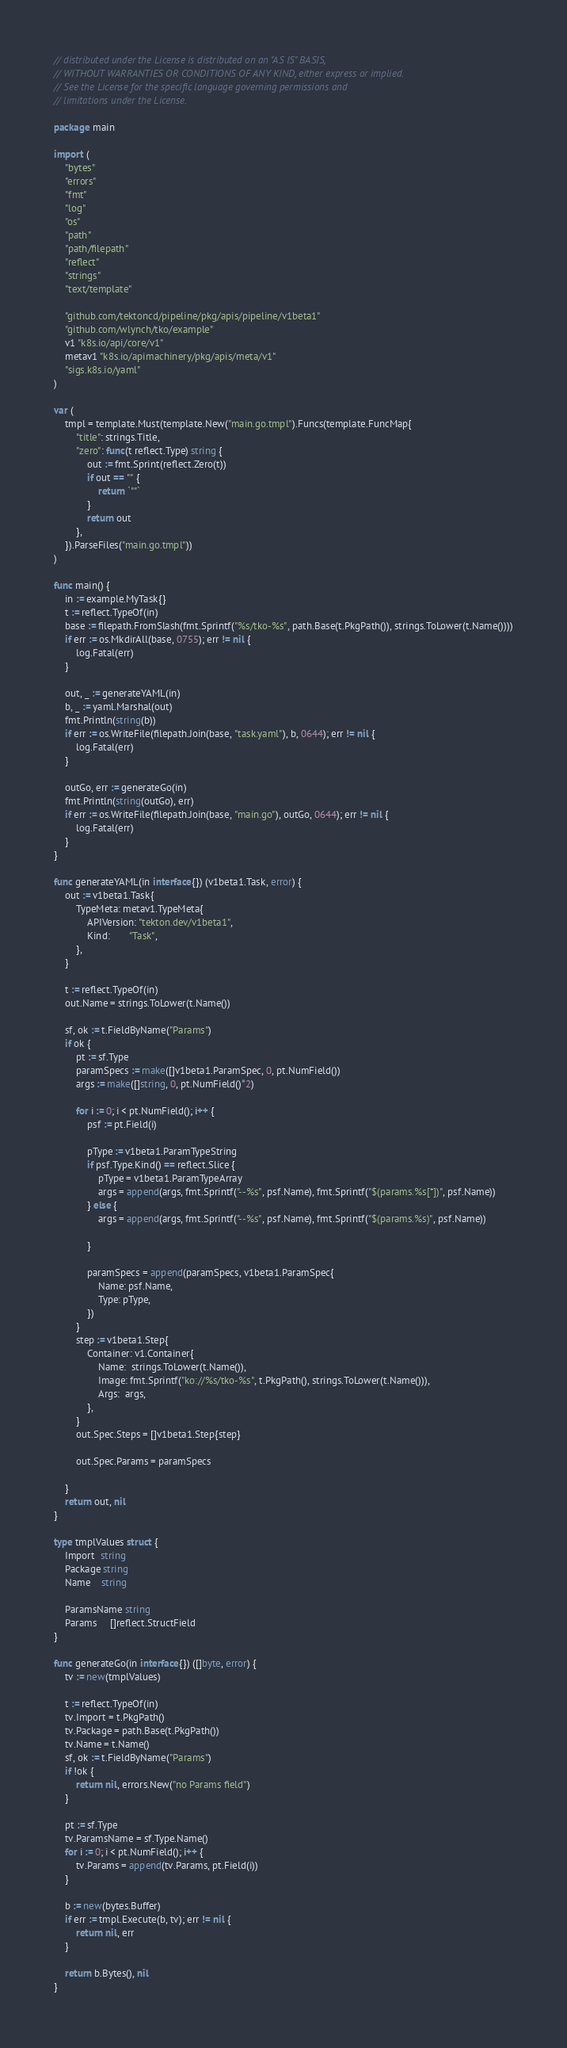Convert code to text. <code><loc_0><loc_0><loc_500><loc_500><_Go_>// distributed under the License is distributed on an "AS IS" BASIS,
// WITHOUT WARRANTIES OR CONDITIONS OF ANY KIND, either express or implied.
// See the License for the specific language governing permissions and
// limitations under the License.

package main

import (
	"bytes"
	"errors"
	"fmt"
	"log"
	"os"
	"path"
	"path/filepath"
	"reflect"
	"strings"
	"text/template"

	"github.com/tektoncd/pipeline/pkg/apis/pipeline/v1beta1"
	"github.com/wlynch/tko/example"
	v1 "k8s.io/api/core/v1"
	metav1 "k8s.io/apimachinery/pkg/apis/meta/v1"
	"sigs.k8s.io/yaml"
)

var (
	tmpl = template.Must(template.New("main.go.tmpl").Funcs(template.FuncMap{
		"title": strings.Title,
		"zero": func(t reflect.Type) string {
			out := fmt.Sprint(reflect.Zero(t))
			if out == "" {
				return `""`
			}
			return out
		},
	}).ParseFiles("main.go.tmpl"))
)

func main() {
	in := example.MyTask{}
	t := reflect.TypeOf(in)
	base := filepath.FromSlash(fmt.Sprintf("%s/tko-%s", path.Base(t.PkgPath()), strings.ToLower(t.Name())))
	if err := os.MkdirAll(base, 0755); err != nil {
		log.Fatal(err)
	}

	out, _ := generateYAML(in)
	b, _ := yaml.Marshal(out)
	fmt.Println(string(b))
	if err := os.WriteFile(filepath.Join(base, "task.yaml"), b, 0644); err != nil {
		log.Fatal(err)
	}

	outGo, err := generateGo(in)
	fmt.Println(string(outGo), err)
	if err := os.WriteFile(filepath.Join(base, "main.go"), outGo, 0644); err != nil {
		log.Fatal(err)
	}
}

func generateYAML(in interface{}) (v1beta1.Task, error) {
	out := v1beta1.Task{
		TypeMeta: metav1.TypeMeta{
			APIVersion: "tekton.dev/v1beta1",
			Kind:       "Task",
		},
	}

	t := reflect.TypeOf(in)
	out.Name = strings.ToLower(t.Name())

	sf, ok := t.FieldByName("Params")
	if ok {
		pt := sf.Type
		paramSpecs := make([]v1beta1.ParamSpec, 0, pt.NumField())
		args := make([]string, 0, pt.NumField()*2)

		for i := 0; i < pt.NumField(); i++ {
			psf := pt.Field(i)

			pType := v1beta1.ParamTypeString
			if psf.Type.Kind() == reflect.Slice {
				pType = v1beta1.ParamTypeArray
				args = append(args, fmt.Sprintf("--%s", psf.Name), fmt.Sprintf("$(params.%s[*])", psf.Name))
			} else {
				args = append(args, fmt.Sprintf("--%s", psf.Name), fmt.Sprintf("$(params.%s)", psf.Name))

			}

			paramSpecs = append(paramSpecs, v1beta1.ParamSpec{
				Name: psf.Name,
				Type: pType,
			})
		}
		step := v1beta1.Step{
			Container: v1.Container{
				Name:  strings.ToLower(t.Name()),
				Image: fmt.Sprintf("ko://%s/tko-%s", t.PkgPath(), strings.ToLower(t.Name())),
				Args:  args,
			},
		}
		out.Spec.Steps = []v1beta1.Step{step}

		out.Spec.Params = paramSpecs

	}
	return out, nil
}

type tmplValues struct {
	Import  string
	Package string
	Name    string

	ParamsName string
	Params     []reflect.StructField
}

func generateGo(in interface{}) ([]byte, error) {
	tv := new(tmplValues)

	t := reflect.TypeOf(in)
	tv.Import = t.PkgPath()
	tv.Package = path.Base(t.PkgPath())
	tv.Name = t.Name()
	sf, ok := t.FieldByName("Params")
	if !ok {
		return nil, errors.New("no Params field")
	}

	pt := sf.Type
	tv.ParamsName = sf.Type.Name()
	for i := 0; i < pt.NumField(); i++ {
		tv.Params = append(tv.Params, pt.Field(i))
	}

	b := new(bytes.Buffer)
	if err := tmpl.Execute(b, tv); err != nil {
		return nil, err
	}

	return b.Bytes(), nil
}
</code> 